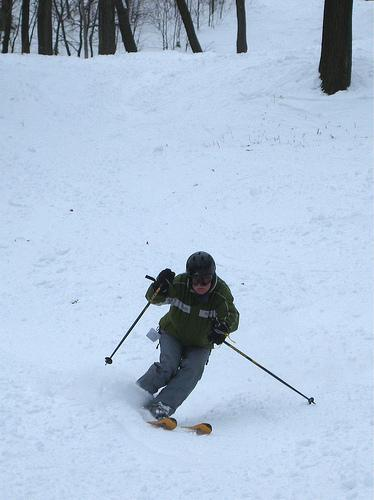Question: when is this taken?
Choices:
A. At night.
B. In the morning.
C. During the day.
D. In the afternoon.
Answer with the letter. Answer: C Question: who is skiing?
Choices:
A. The boy.
B. The girl.
C. The man.
D. The woman.
Answer with the letter. Answer: C Question: what color is the snow?
Choices:
A. Yellow.
B. Grey.
C. Black.
D. White.
Answer with the letter. Answer: D Question: what color is the man's jacket?
Choices:
A. Green.
B. Red.
C. White.
D. Yellow.
Answer with the letter. Answer: A Question: what is the man doing?
Choices:
A. He is skiing.
B. Running.
C. Walking.
D. Shopping.
Answer with the letter. Answer: A Question: where is the man?
Choices:
A. In the trees.
B. In the grass.
C. In the snow.
D. In the leaves.
Answer with the letter. Answer: C 